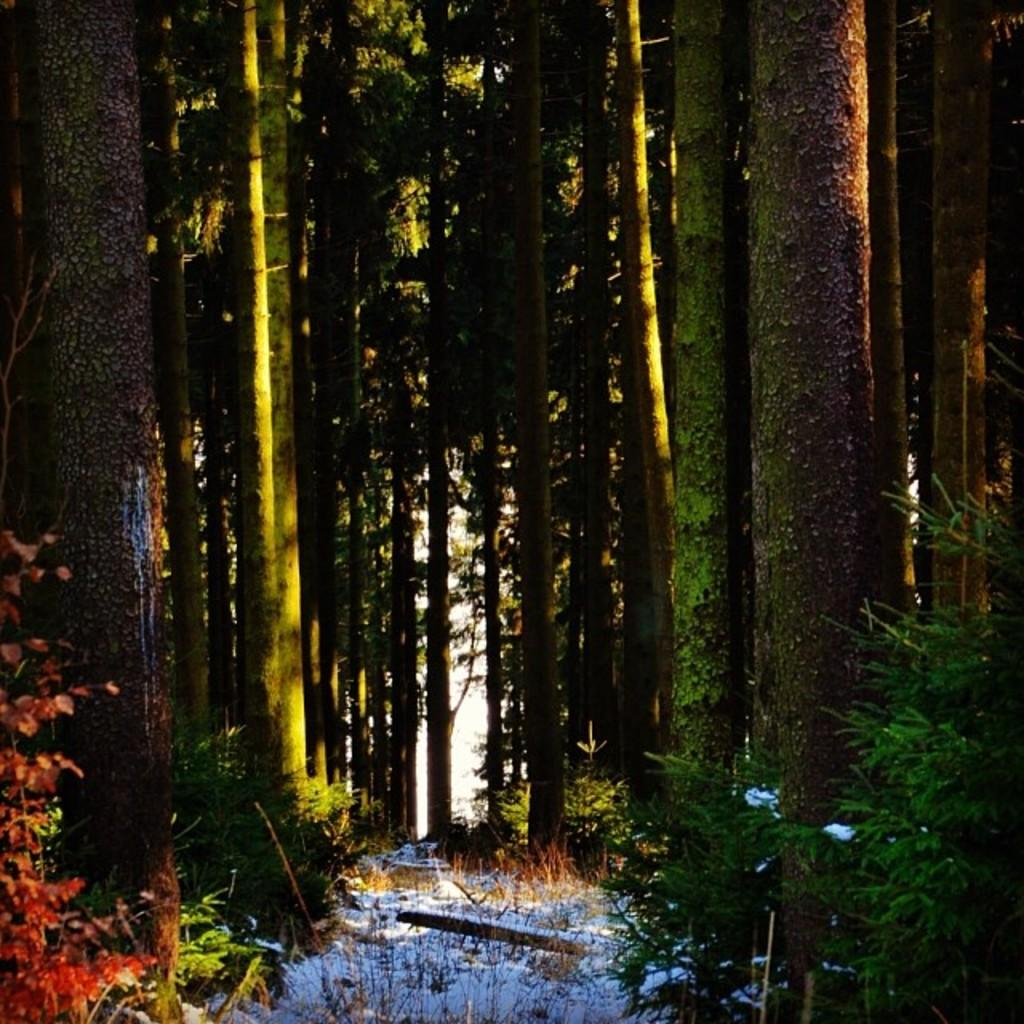What type of vegetation is visible in the image? There are trees in the image. What is covering the ground in the image? There is snow at the bottom of the image. What type of button can be seen on the trees in the image? There are no buttons present on the trees in the image. Is there a bomb hidden in the snow in the image? There is no bomb present in the image; it only features trees and snow. Can you see any blades, such as a sword or knife, in the image? There are no blades present in the image; it only features trees and snow. 